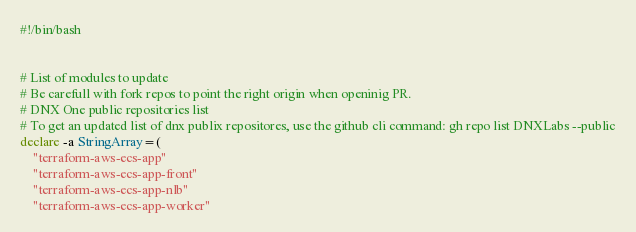Convert code to text. <code><loc_0><loc_0><loc_500><loc_500><_Bash_>#!/bin/bash


# List of modules to update
# Be carefull with fork repos to point the right origin when openinig PR.
# DNX One public repositories list
# To get an updated list of dnx publix repositores, use the github cli command: gh repo list DNXLabs --public
declare -a StringArray=(
    "terraform-aws-ecs-app"
    "terraform-aws-ecs-app-front"
    "terraform-aws-ecs-app-nlb"
    "terraform-aws-ecs-app-worker"</code> 